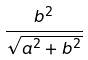<formula> <loc_0><loc_0><loc_500><loc_500>\frac { b ^ { 2 } } { \sqrt { a ^ { 2 } + b ^ { 2 } } }</formula> 